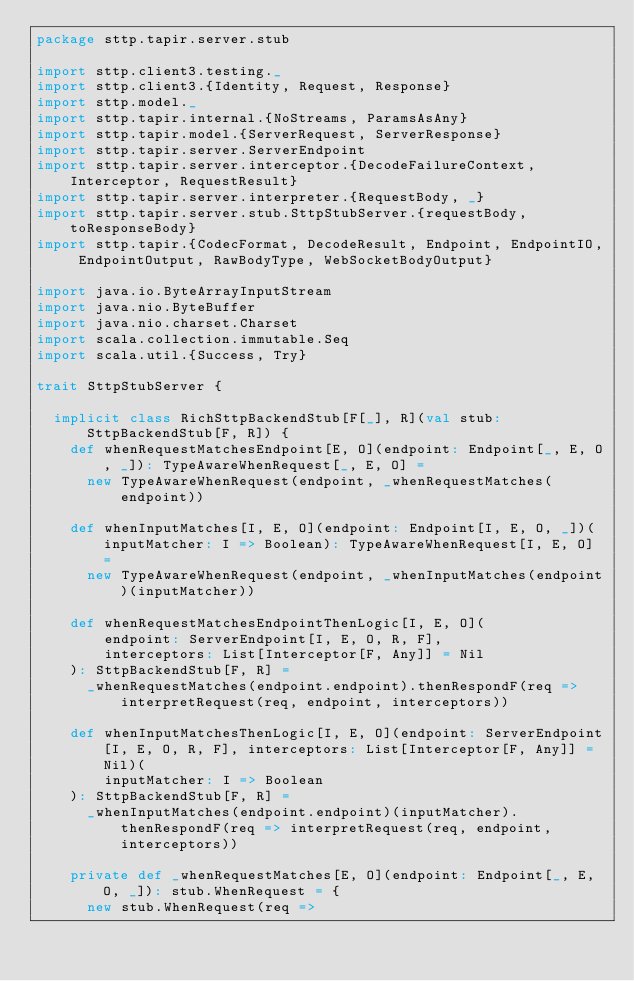<code> <loc_0><loc_0><loc_500><loc_500><_Scala_>package sttp.tapir.server.stub

import sttp.client3.testing._
import sttp.client3.{Identity, Request, Response}
import sttp.model._
import sttp.tapir.internal.{NoStreams, ParamsAsAny}
import sttp.tapir.model.{ServerRequest, ServerResponse}
import sttp.tapir.server.ServerEndpoint
import sttp.tapir.server.interceptor.{DecodeFailureContext, Interceptor, RequestResult}
import sttp.tapir.server.interpreter.{RequestBody, _}
import sttp.tapir.server.stub.SttpStubServer.{requestBody, toResponseBody}
import sttp.tapir.{CodecFormat, DecodeResult, Endpoint, EndpointIO, EndpointOutput, RawBodyType, WebSocketBodyOutput}

import java.io.ByteArrayInputStream
import java.nio.ByteBuffer
import java.nio.charset.Charset
import scala.collection.immutable.Seq
import scala.util.{Success, Try}

trait SttpStubServer {

  implicit class RichSttpBackendStub[F[_], R](val stub: SttpBackendStub[F, R]) {
    def whenRequestMatchesEndpoint[E, O](endpoint: Endpoint[_, E, O, _]): TypeAwareWhenRequest[_, E, O] =
      new TypeAwareWhenRequest(endpoint, _whenRequestMatches(endpoint))

    def whenInputMatches[I, E, O](endpoint: Endpoint[I, E, O, _])(inputMatcher: I => Boolean): TypeAwareWhenRequest[I, E, O] =
      new TypeAwareWhenRequest(endpoint, _whenInputMatches(endpoint)(inputMatcher))

    def whenRequestMatchesEndpointThenLogic[I, E, O](
        endpoint: ServerEndpoint[I, E, O, R, F],
        interceptors: List[Interceptor[F, Any]] = Nil
    ): SttpBackendStub[F, R] =
      _whenRequestMatches(endpoint.endpoint).thenRespondF(req => interpretRequest(req, endpoint, interceptors))

    def whenInputMatchesThenLogic[I, E, O](endpoint: ServerEndpoint[I, E, O, R, F], interceptors: List[Interceptor[F, Any]] = Nil)(
        inputMatcher: I => Boolean
    ): SttpBackendStub[F, R] =
      _whenInputMatches(endpoint.endpoint)(inputMatcher).thenRespondF(req => interpretRequest(req, endpoint, interceptors))

    private def _whenRequestMatches[E, O](endpoint: Endpoint[_, E, O, _]): stub.WhenRequest = {
      new stub.WhenRequest(req =></code> 